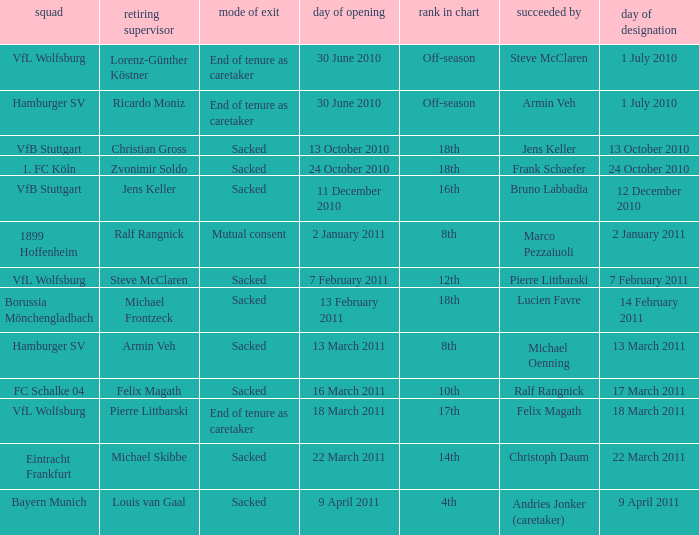When steve mcclaren is the replacer what is the manner of departure? End of tenure as caretaker. 